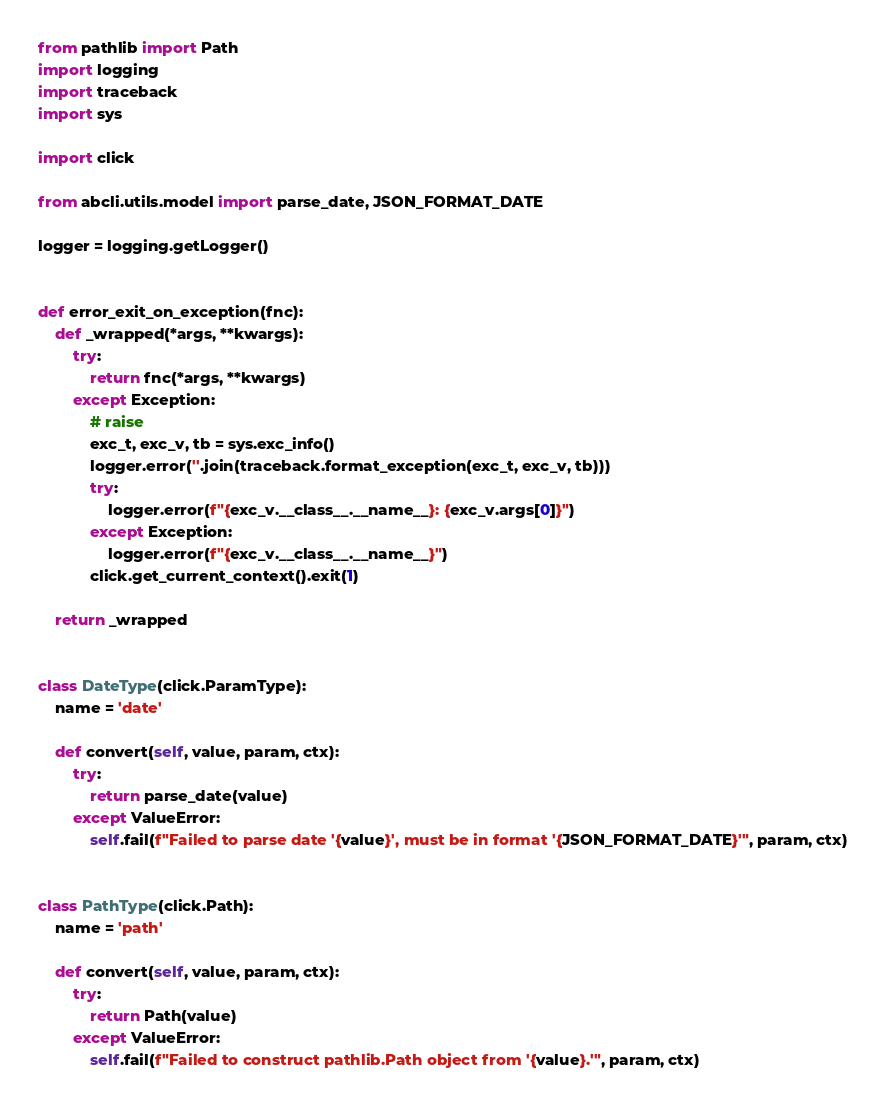<code> <loc_0><loc_0><loc_500><loc_500><_Python_>from pathlib import Path
import logging
import traceback
import sys

import click

from abcli.utils.model import parse_date, JSON_FORMAT_DATE

logger = logging.getLogger()


def error_exit_on_exception(fnc):
    def _wrapped(*args, **kwargs):
        try:
            return fnc(*args, **kwargs)
        except Exception:
            # raise
            exc_t, exc_v, tb = sys.exc_info()
            logger.error(''.join(traceback.format_exception(exc_t, exc_v, tb)))
            try:
                logger.error(f"{exc_v.__class__.__name__}: {exc_v.args[0]}")
            except Exception:
                logger.error(f"{exc_v.__class__.__name__}")
            click.get_current_context().exit(1)

    return _wrapped


class DateType(click.ParamType):
    name = 'date'

    def convert(self, value, param, ctx):
        try:
            return parse_date(value)
        except ValueError:
            self.fail(f"Failed to parse date '{value}', must be in format '{JSON_FORMAT_DATE}'", param, ctx)


class PathType(click.Path):
    name = 'path'

    def convert(self, value, param, ctx):
        try:
            return Path(value)
        except ValueError:
            self.fail(f"Failed to construct pathlib.Path object from '{value}.'", param, ctx)
</code> 